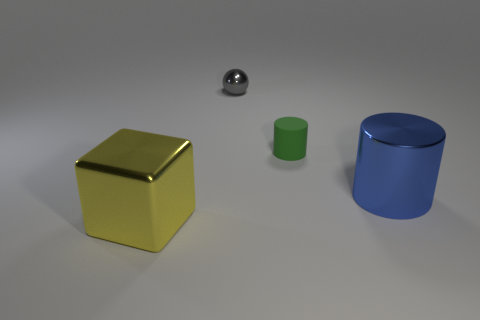What number of other objects are there of the same material as the small green object?
Provide a short and direct response. 0. Do the blue thing and the yellow object have the same size?
Your answer should be very brief. Yes. What number of things are cylinders that are right of the small green rubber object or matte things?
Your answer should be very brief. 2. What material is the cylinder left of the big metal object behind the metallic block?
Make the answer very short. Rubber. Is there a matte thing of the same shape as the gray metal thing?
Ensure brevity in your answer.  No. Does the yellow metal block have the same size as the cylinder in front of the tiny cylinder?
Provide a succinct answer. Yes. How many objects are either shiny things that are to the right of the green rubber cylinder or things that are behind the big yellow cube?
Provide a succinct answer. 3. Is the number of large cylinders left of the tiny green thing greater than the number of blue things?
Make the answer very short. No. What number of yellow shiny cubes have the same size as the rubber cylinder?
Offer a terse response. 0. There is a metal thing on the right side of the small rubber object; is it the same size as the thing that is to the left of the small metallic sphere?
Give a very brief answer. Yes. 